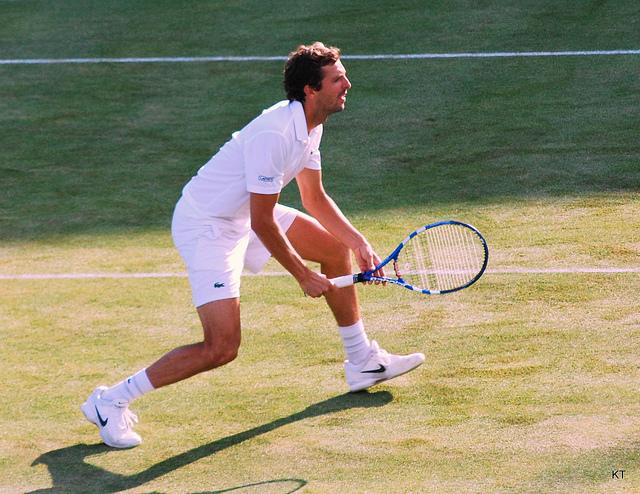What brand shoe is the man wearing?
Answer briefly. Nike. What brand of shoes is he wearing?
Short answer required. Nike. Is he waiting for a Shuttlecock?
Be succinct. No. Why is he wearing white?
Keep it brief. Common color for tennis clothes. 